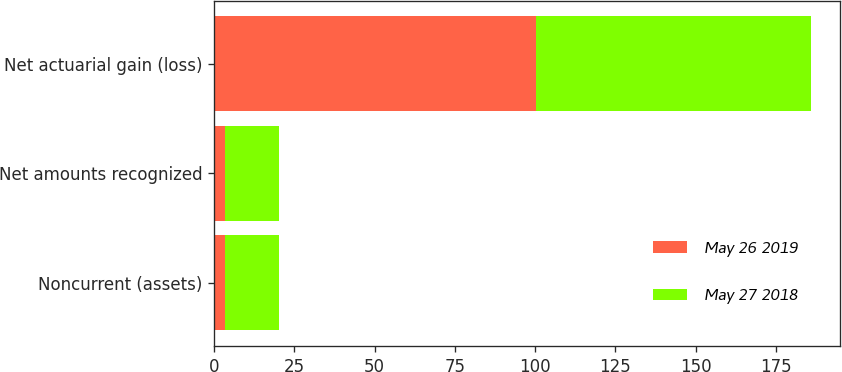<chart> <loc_0><loc_0><loc_500><loc_500><stacked_bar_chart><ecel><fcel>Noncurrent (assets)<fcel>Net amounts recognized<fcel>Net actuarial gain (loss)<nl><fcel>May 26 2019<fcel>3.5<fcel>3.5<fcel>100.4<nl><fcel>May 27 2018<fcel>16.6<fcel>16.6<fcel>85.4<nl></chart> 